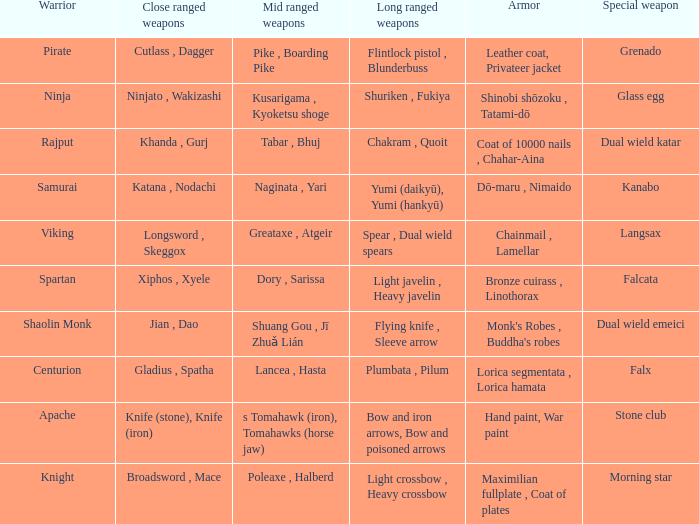If the armor is bronze cuirass , linothorax, what are the close ranged weapons? Xiphos , Xyele. 